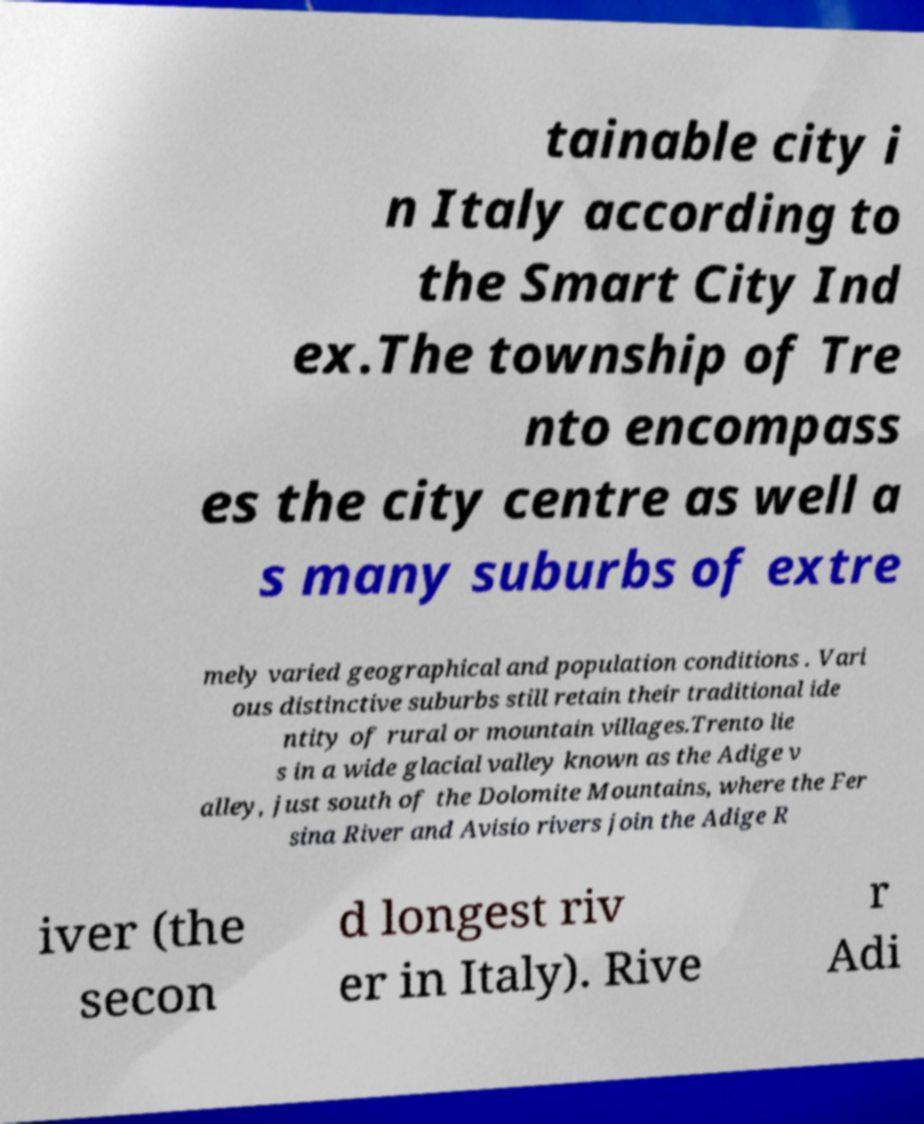I need the written content from this picture converted into text. Can you do that? tainable city i n Italy according to the Smart City Ind ex.The township of Tre nto encompass es the city centre as well a s many suburbs of extre mely varied geographical and population conditions . Vari ous distinctive suburbs still retain their traditional ide ntity of rural or mountain villages.Trento lie s in a wide glacial valley known as the Adige v alley, just south of the Dolomite Mountains, where the Fer sina River and Avisio rivers join the Adige R iver (the secon d longest riv er in Italy). Rive r Adi 